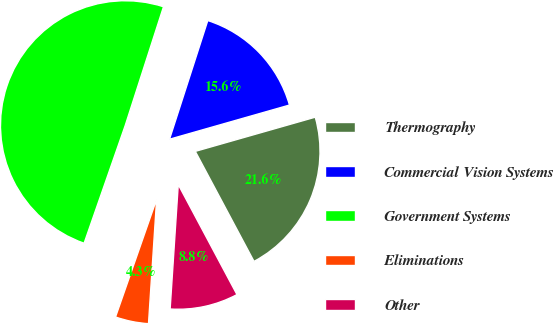Convert chart to OTSL. <chart><loc_0><loc_0><loc_500><loc_500><pie_chart><fcel>Thermography<fcel>Commercial Vision Systems<fcel>Government Systems<fcel>Eliminations<fcel>Other<nl><fcel>21.62%<fcel>15.62%<fcel>49.62%<fcel>4.31%<fcel>8.84%<nl></chart> 